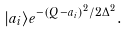Convert formula to latex. <formula><loc_0><loc_0><loc_500><loc_500>| a _ { i } \rangle e ^ { - { { ( Q - a _ { i } ) ^ { 2 } } / { 2 \Delta ^ { 2 } } } } .</formula> 